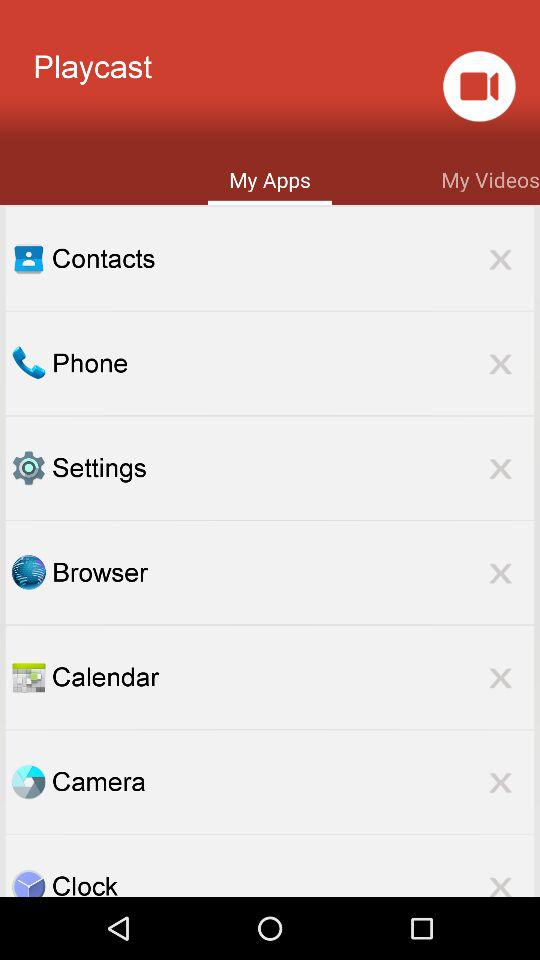Which tab of "Playcast" am I on? You are on the "My Apps" tab of "Playcast". 